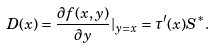<formula> <loc_0><loc_0><loc_500><loc_500>D ( x ) = \frac { \partial f ( x , y ) } { \partial y } | _ { y = x } = \tau ^ { \prime } ( x ) S ^ { * } .</formula> 